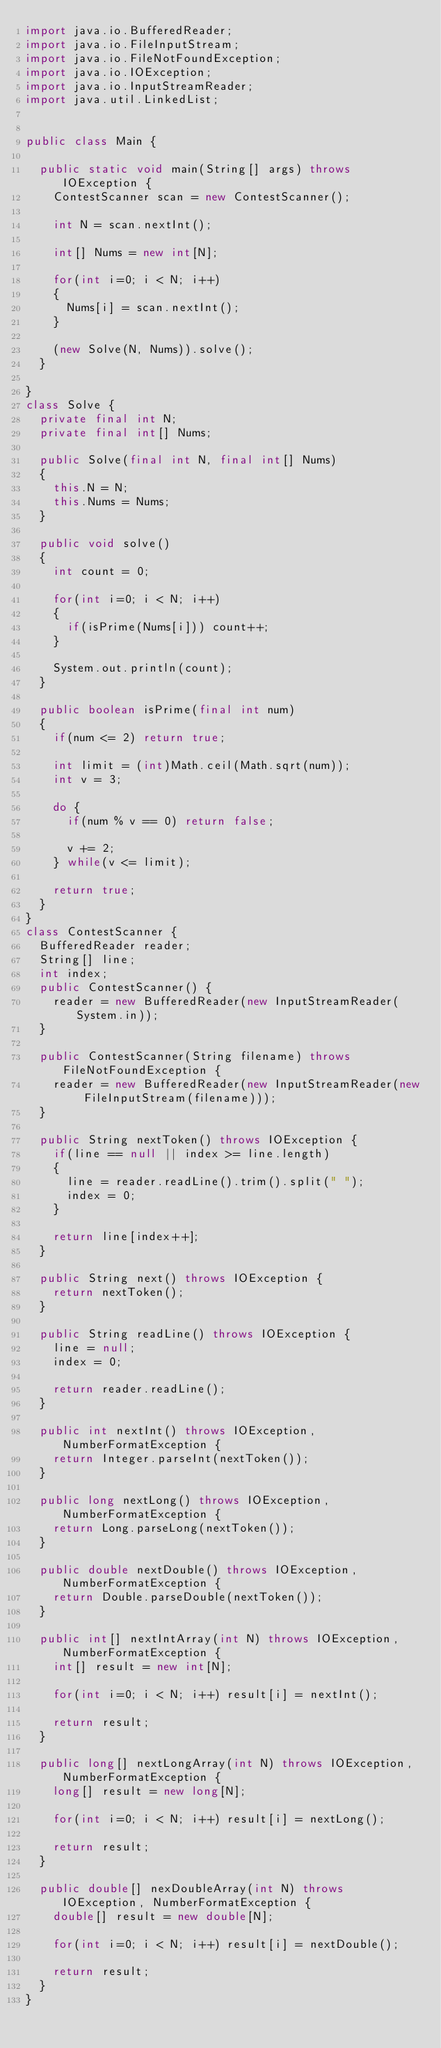Convert code to text. <code><loc_0><loc_0><loc_500><loc_500><_Java_>import java.io.BufferedReader;
import java.io.FileInputStream;
import java.io.FileNotFoundException;
import java.io.IOException;
import java.io.InputStreamReader;
import java.util.LinkedList;


public class Main {

	public static void main(String[] args) throws IOException {
		ContestScanner scan = new ContestScanner();

		int N = scan.nextInt();

		int[] Nums = new int[N];

		for(int i=0; i < N; i++)
		{
			Nums[i] = scan.nextInt();
		}

		(new Solve(N, Nums)).solve();
	}

}
class Solve {
	private final int N;
	private final int[] Nums;

	public Solve(final int N, final int[] Nums)
	{
		this.N = N;
		this.Nums = Nums;
	}

	public void solve()
	{
		int count = 0;

		for(int i=0; i < N; i++)
		{
			if(isPrime(Nums[i])) count++;
		}

		System.out.println(count);
	}

	public boolean isPrime(final int num)
	{
		if(num <= 2) return true;

		int limit = (int)Math.ceil(Math.sqrt(num));
		int v = 3;

		do {
			if(num % v == 0) return false;

			v += 2;
		} while(v <= limit);

		return true;
	}
}
class ContestScanner {
	BufferedReader reader;
	String[] line;
	int index;
	public ContestScanner() {
		reader = new BufferedReader(new InputStreamReader(System.in));
	}

	public ContestScanner(String filename) throws FileNotFoundException {
		reader = new BufferedReader(new InputStreamReader(new FileInputStream(filename)));
	}

	public String nextToken() throws IOException {
		if(line == null || index >= line.length)
		{
			line = reader.readLine().trim().split(" ");
			index = 0;
		}

		return line[index++];
	}

	public String next() throws IOException {
		return nextToken();
	}

	public String readLine() throws IOException {
		line = null;
		index = 0;

		return reader.readLine();
	}

	public int nextInt() throws IOException, NumberFormatException {
		return Integer.parseInt(nextToken());
	}

	public long nextLong() throws IOException, NumberFormatException {
		return Long.parseLong(nextToken());
	}

	public double nextDouble() throws IOException, NumberFormatException {
		return Double.parseDouble(nextToken());
	}

	public int[] nextIntArray(int N) throws IOException, NumberFormatException {
		int[] result = new int[N];

		for(int i=0; i < N; i++) result[i] = nextInt();

		return result;
	}

	public long[] nextLongArray(int N) throws IOException, NumberFormatException {
		long[] result = new long[N];

		for(int i=0; i < N; i++) result[i] = nextLong();

		return result;
	}

	public double[] nexDoubleArray(int N) throws IOException, NumberFormatException {
		double[] result = new double[N];

		for(int i=0; i < N; i++) result[i] = nextDouble();

		return result;
	}
}</code> 